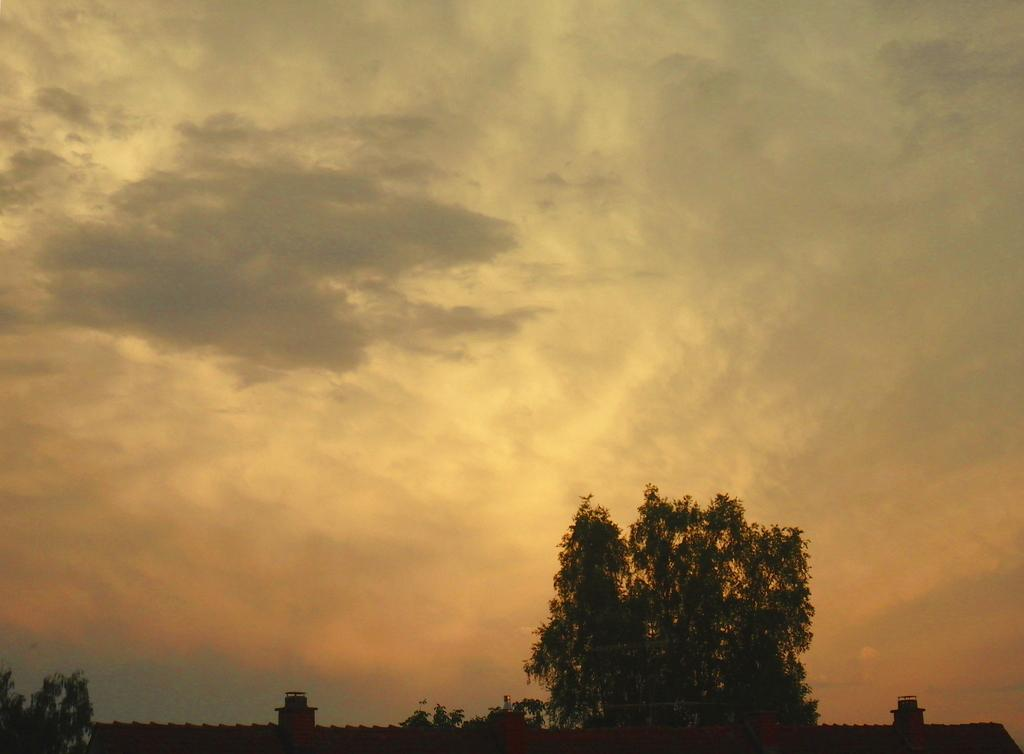What type of vegetation can be seen in the image? There are trees in the image. What is the condition of the sky in the image? The sky is clouded in the image. How many cats are visible in the image? There are no cats present in the image. What type of cough can be heard in the image? There is no sound, including coughing, present in the image. 